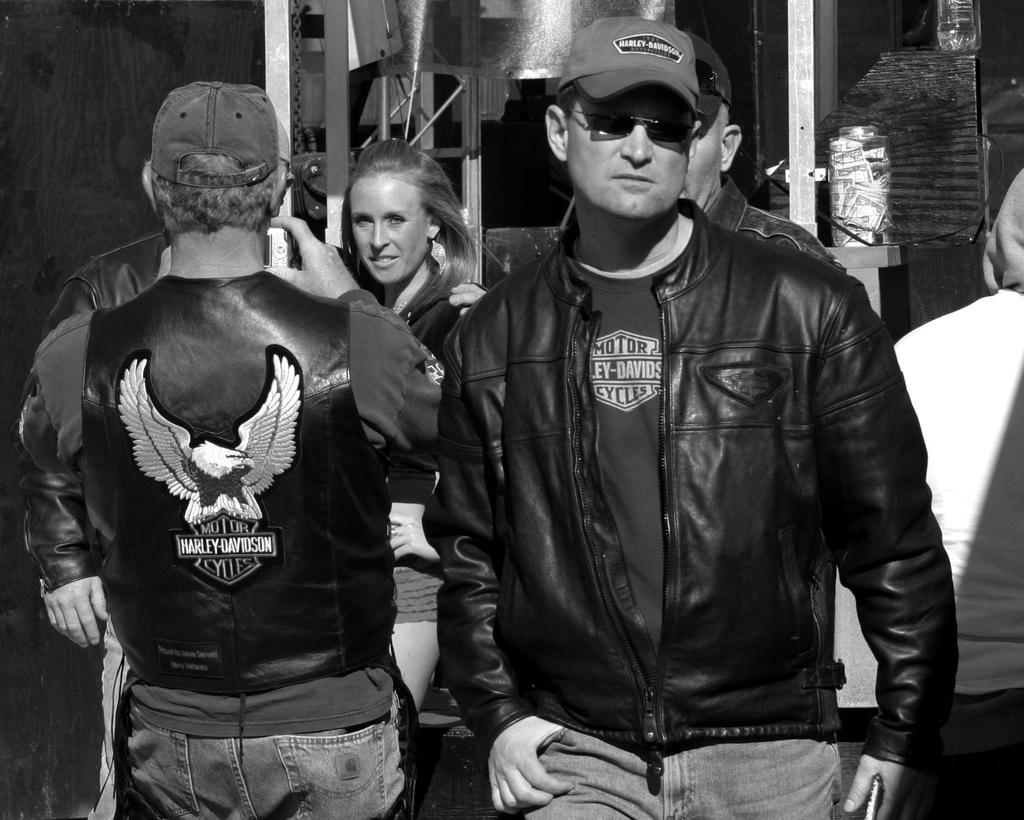What is the color scheme of the image? The image is black and white. Can you describe the people in the image? There are people in the image, and some of them are wearing caps. What is one person doing in the image? There is a person holding a camera. What can be seen in the background of the image? The background includes rods, walls, and other objects. What type of cord is being used to tie the balloons together at the party in the image? There is no party or balloons present in the image; it is a black and white image with people, caps, a camera, and a background with rods and walls. 